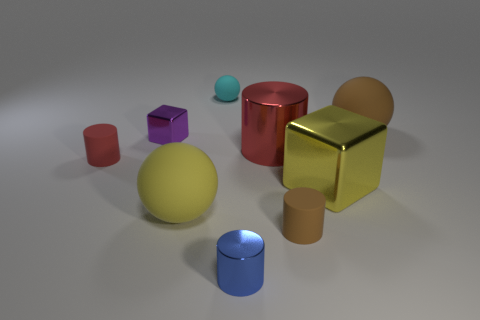How many geometric shapes can you identify in this image? There are eight distinct geometric shapes visible in the image: a small blue cylinder, a medium red cylinder, a large yellow sphere, a small red cube, a medium-sized gold cube, a small tan cylinder, a small violet cube, and a small teal sphere. Which of these shapes are closest to the foreground of the image? The gold cube and the small red cube are the closest to the foreground of the image. 